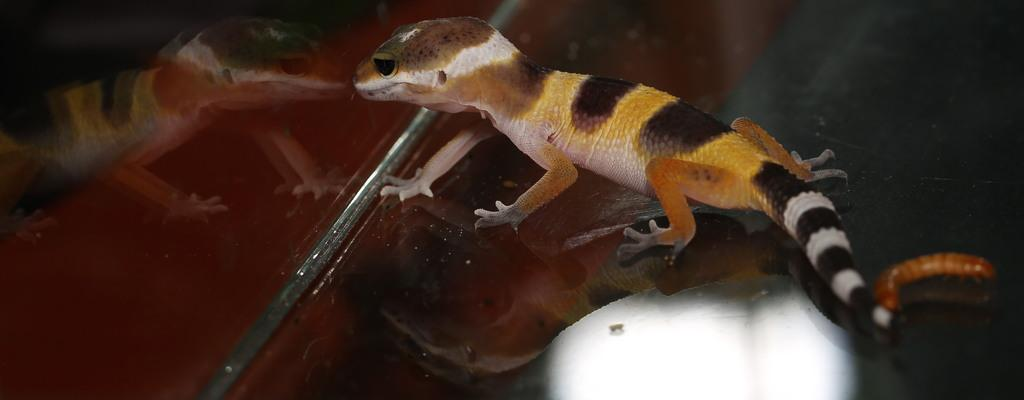What type of animal is in the image? There is a house gecko in the image. Can you describe the appearance of the house gecko? The house gecko is multicolored. What type of bird can be seen flying in the image? There is no bird present in the image; it features a house gecko. Is there an airplane visible in the image? No, there is no airplane present in the image. 